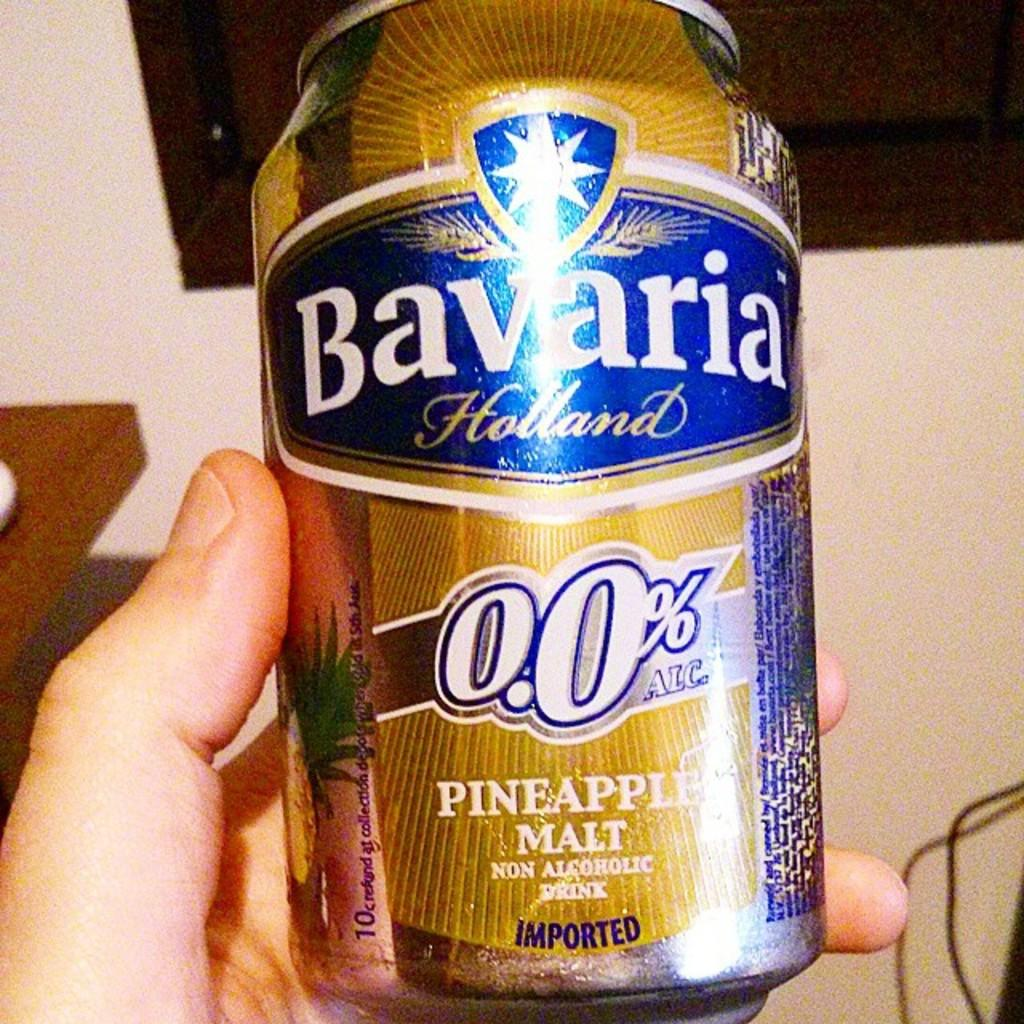<image>
Render a clear and concise summary of the photo. Someone is holding a can of Bavaria pineapple malt. 